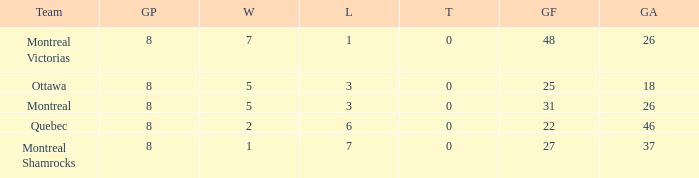For teams with 7 wins, what is the number of goals against? 26.0. 